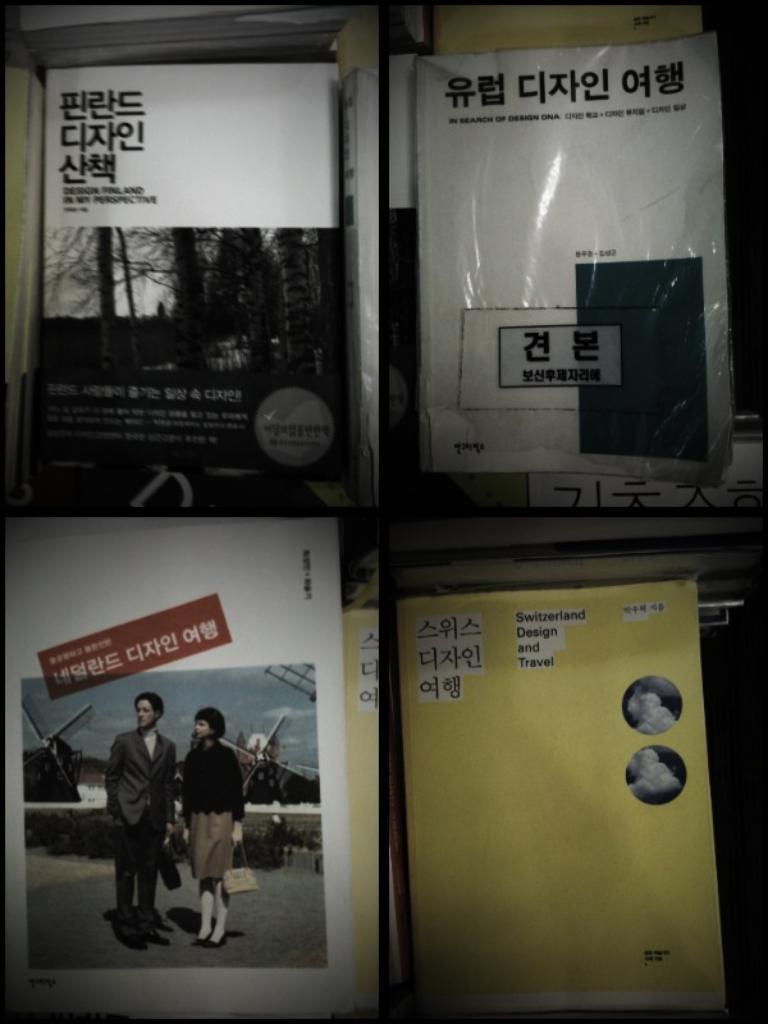How would you summarize this image in a sentence or two? In this image we can see a collage image. In this image we can see different types of posters with some text and pictures. 